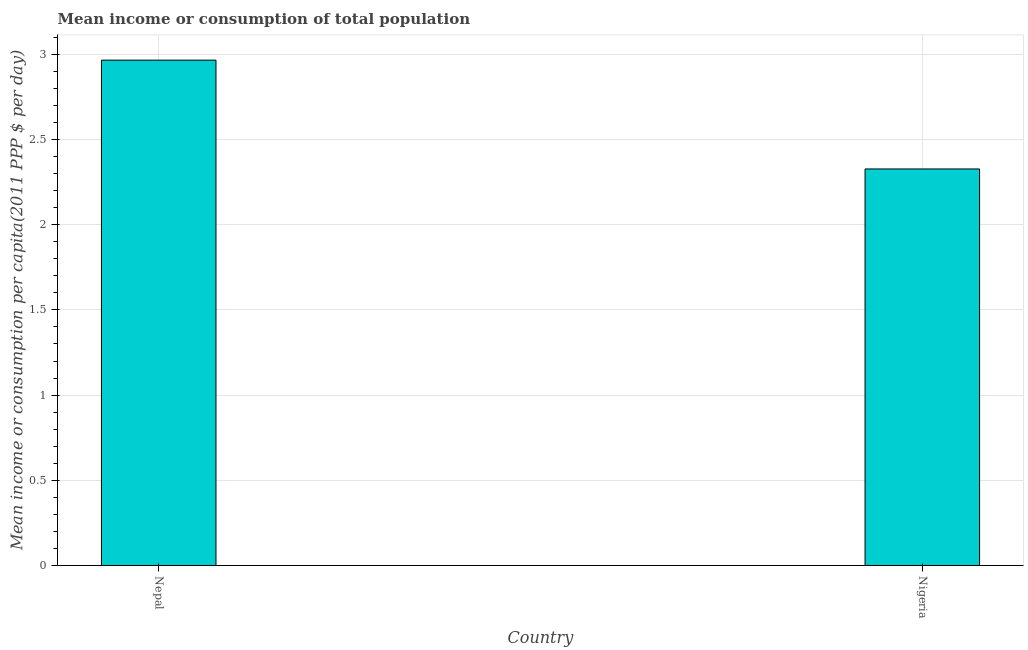Does the graph contain any zero values?
Offer a very short reply. No. What is the title of the graph?
Your answer should be very brief. Mean income or consumption of total population. What is the label or title of the Y-axis?
Provide a succinct answer. Mean income or consumption per capita(2011 PPP $ per day). What is the mean income or consumption in Nepal?
Your response must be concise. 2.97. Across all countries, what is the maximum mean income or consumption?
Ensure brevity in your answer.  2.97. Across all countries, what is the minimum mean income or consumption?
Your answer should be compact. 2.33. In which country was the mean income or consumption maximum?
Your response must be concise. Nepal. In which country was the mean income or consumption minimum?
Your answer should be very brief. Nigeria. What is the sum of the mean income or consumption?
Your answer should be compact. 5.29. What is the difference between the mean income or consumption in Nepal and Nigeria?
Keep it short and to the point. 0.64. What is the average mean income or consumption per country?
Provide a short and direct response. 2.65. What is the median mean income or consumption?
Ensure brevity in your answer.  2.65. What is the ratio of the mean income or consumption in Nepal to that in Nigeria?
Your response must be concise. 1.27. In how many countries, is the mean income or consumption greater than the average mean income or consumption taken over all countries?
Give a very brief answer. 1. Are all the bars in the graph horizontal?
Provide a succinct answer. No. How many countries are there in the graph?
Your response must be concise. 2. Are the values on the major ticks of Y-axis written in scientific E-notation?
Provide a short and direct response. No. What is the Mean income or consumption per capita(2011 PPP $ per day) of Nepal?
Keep it short and to the point. 2.97. What is the Mean income or consumption per capita(2011 PPP $ per day) of Nigeria?
Offer a very short reply. 2.33. What is the difference between the Mean income or consumption per capita(2011 PPP $ per day) in Nepal and Nigeria?
Your answer should be very brief. 0.64. What is the ratio of the Mean income or consumption per capita(2011 PPP $ per day) in Nepal to that in Nigeria?
Ensure brevity in your answer.  1.27. 